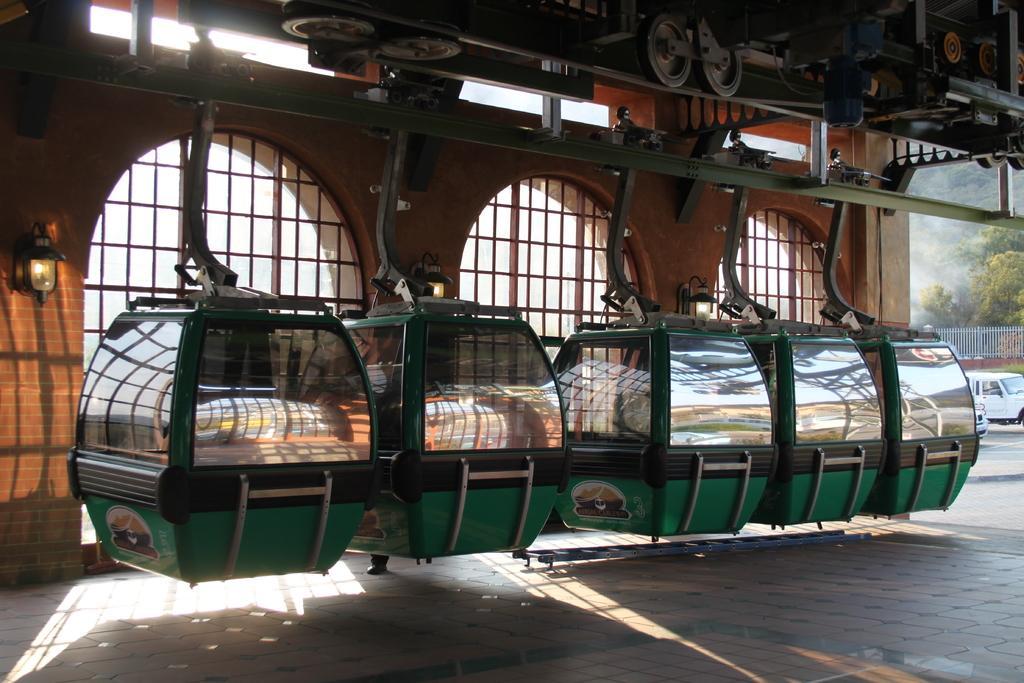Could you give a brief overview of what you see in this image? In this image we can see ropeways, poles, mechanical instruments, wheels, there are windows, lights, trees, there is a vehicle, also we can see the wall. 